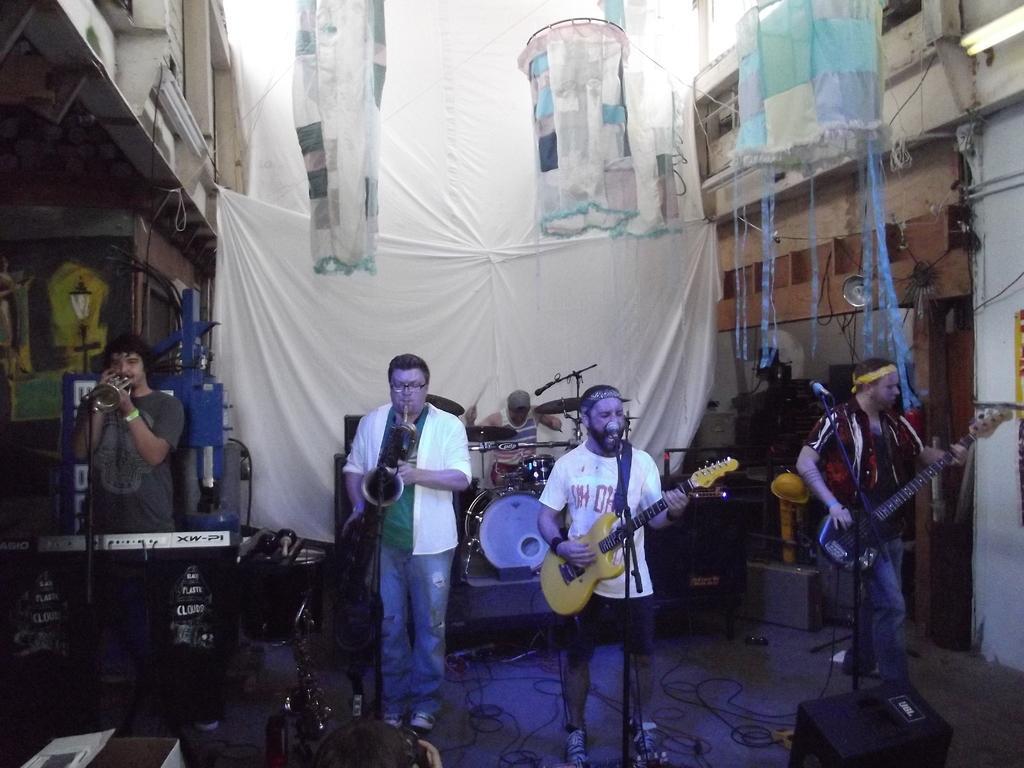Could you give a brief overview of what you see in this image? In this image there are people playing musical instruments. In front of them there are mike's. Behind them there is another person playing musical instruments. On both right and left side of the image there are buildings. In the background of the image there are banners. At the bottom of the image there are wires on the surface. 